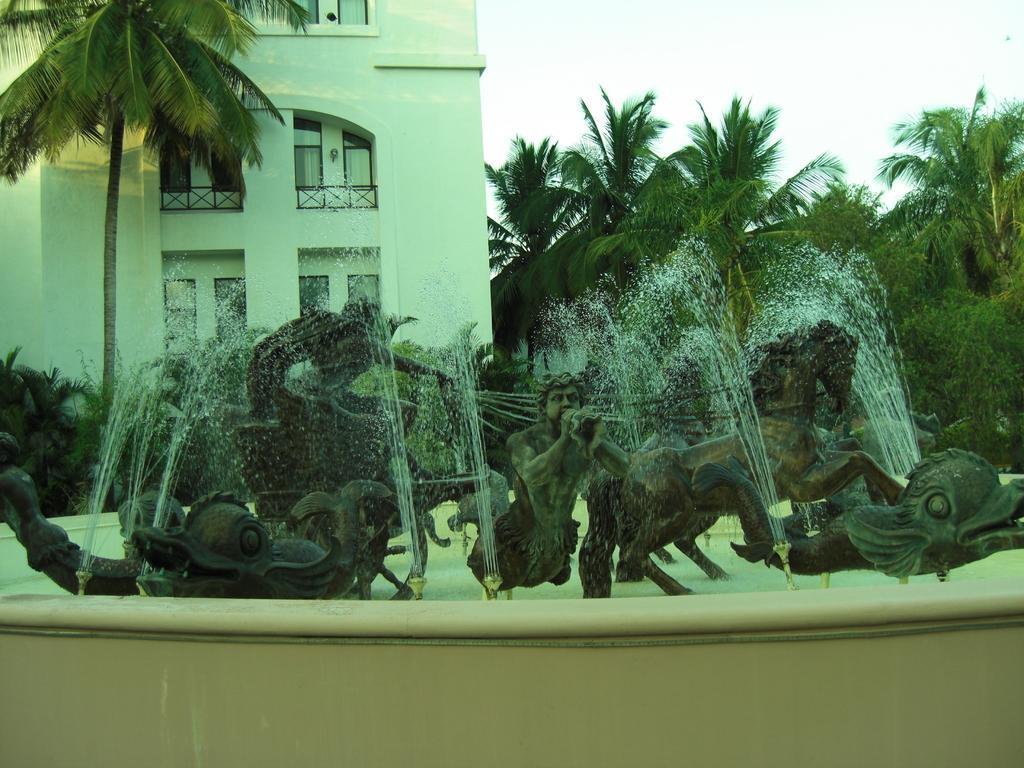Can you describe this image briefly? In the image we can see sculptures and a water fountain. There are even trees and a building and these are the windows of the building and the sky. 